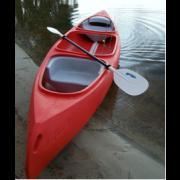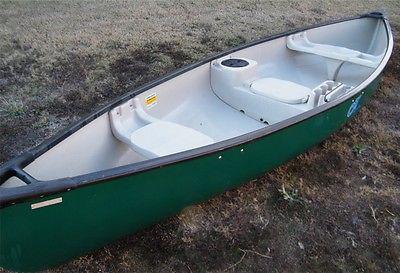The first image is the image on the left, the second image is the image on the right. Analyze the images presented: Is the assertion "The left image has a red canoe with a paddle on it." valid? Answer yes or no. Yes. The first image is the image on the left, the second image is the image on the right. Given the left and right images, does the statement "All of the canoes and kayaks have oars on them." hold true? Answer yes or no. No. 